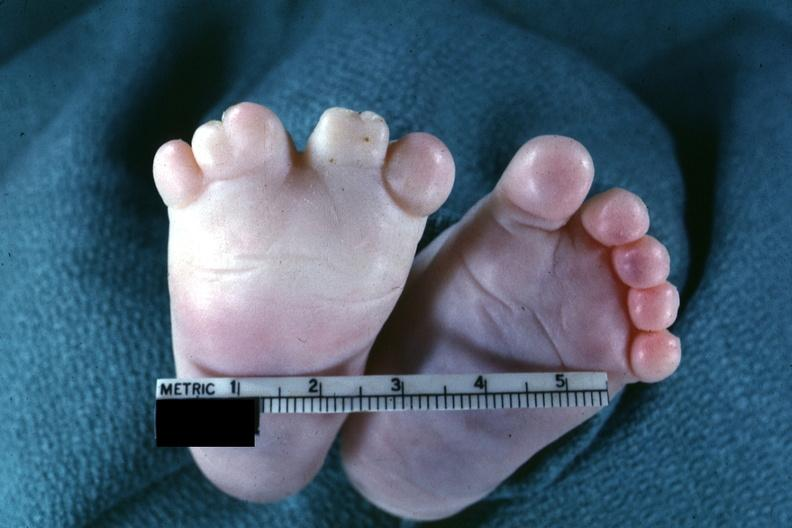does this image show very good example of syndactyly?
Answer the question using a single word or phrase. Yes 